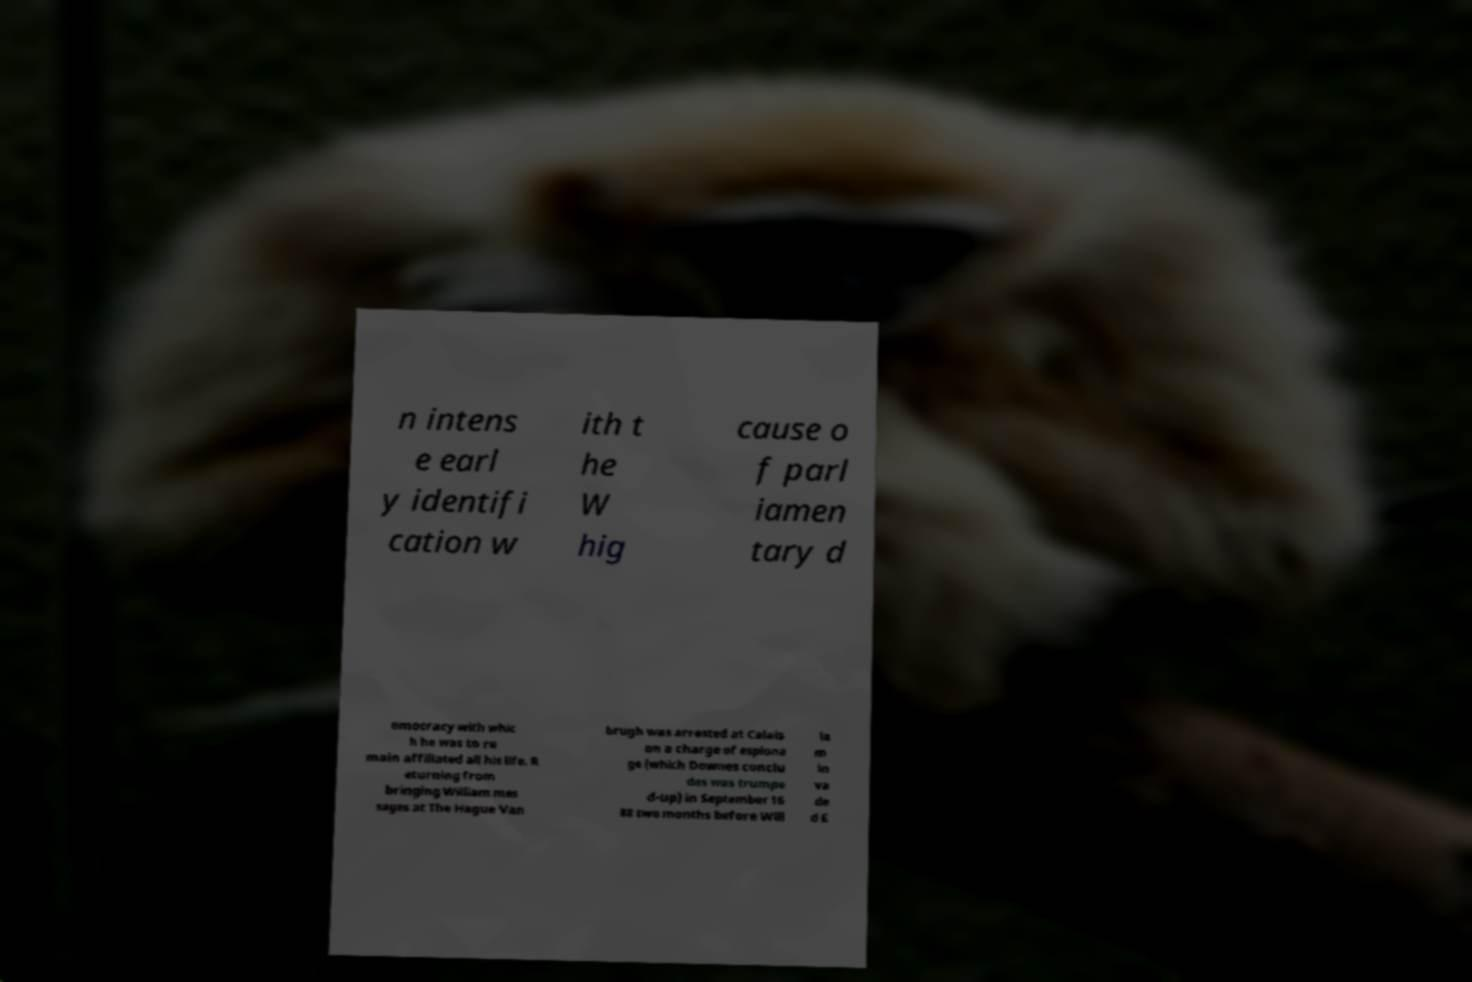For documentation purposes, I need the text within this image transcribed. Could you provide that? n intens e earl y identifi cation w ith t he W hig cause o f parl iamen tary d emocracy with whic h he was to re main affiliated all his life. R eturning from bringing William mes sages at The Hague Van brugh was arrested at Calais on a charge of espiona ge (which Downes conclu des was trumpe d-up) in September 16 88 two months before Will ia m in va de d E 